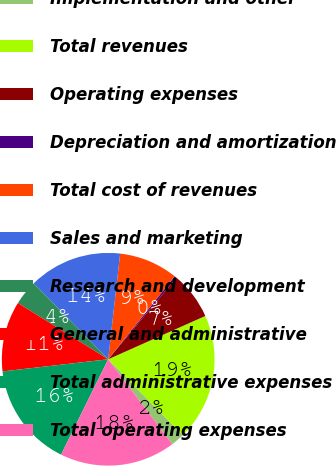Convert chart. <chart><loc_0><loc_0><loc_500><loc_500><pie_chart><fcel>Implementation and other<fcel>Total revenues<fcel>Operating expenses<fcel>Depreciation and amortization<fcel>Total cost of revenues<fcel>Sales and marketing<fcel>Research and development<fcel>General and administrative<fcel>Total administrative expenses<fcel>Total operating expenses<nl><fcel>2.06%<fcel>19.32%<fcel>7.24%<fcel>0.33%<fcel>8.96%<fcel>14.14%<fcel>3.78%<fcel>10.69%<fcel>15.87%<fcel>17.6%<nl></chart> 